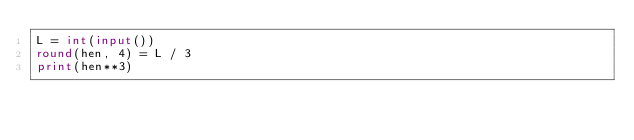Convert code to text. <code><loc_0><loc_0><loc_500><loc_500><_Python_>L = int(input())
round(hen, 4) = L / 3
print(hen**3)</code> 